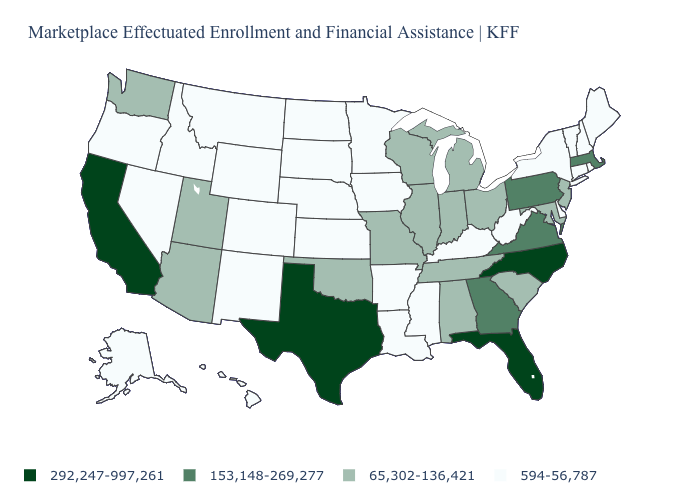Does the first symbol in the legend represent the smallest category?
Quick response, please. No. Does Vermont have the same value as Idaho?
Quick response, please. Yes. Name the states that have a value in the range 594-56,787?
Answer briefly. Alaska, Arkansas, Colorado, Connecticut, Delaware, Hawaii, Idaho, Iowa, Kansas, Kentucky, Louisiana, Maine, Minnesota, Mississippi, Montana, Nebraska, Nevada, New Hampshire, New Mexico, New York, North Dakota, Oregon, Rhode Island, South Dakota, Vermont, West Virginia, Wyoming. Which states have the lowest value in the West?
Keep it brief. Alaska, Colorado, Hawaii, Idaho, Montana, Nevada, New Mexico, Oregon, Wyoming. What is the value of Oklahoma?
Concise answer only. 65,302-136,421. Among the states that border Nebraska , which have the lowest value?
Quick response, please. Colorado, Iowa, Kansas, South Dakota, Wyoming. Does New York have the same value as Alabama?
Give a very brief answer. No. What is the lowest value in the Northeast?
Quick response, please. 594-56,787. Which states have the highest value in the USA?
Write a very short answer. California, Florida, North Carolina, Texas. What is the value of Maryland?
Write a very short answer. 65,302-136,421. What is the highest value in the USA?
Short answer required. 292,247-997,261. Name the states that have a value in the range 65,302-136,421?
Keep it brief. Alabama, Arizona, Illinois, Indiana, Maryland, Michigan, Missouri, New Jersey, Ohio, Oklahoma, South Carolina, Tennessee, Utah, Washington, Wisconsin. Does the map have missing data?
Answer briefly. No. What is the lowest value in the USA?
Quick response, please. 594-56,787. Among the states that border Louisiana , does Mississippi have the highest value?
Be succinct. No. 